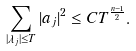<formula> <loc_0><loc_0><loc_500><loc_500>\sum _ { | \lambda _ { j } | \leq T } | a _ { j } | ^ { 2 } \leq C T ^ { \frac { n - 1 } { 2 } } .</formula> 